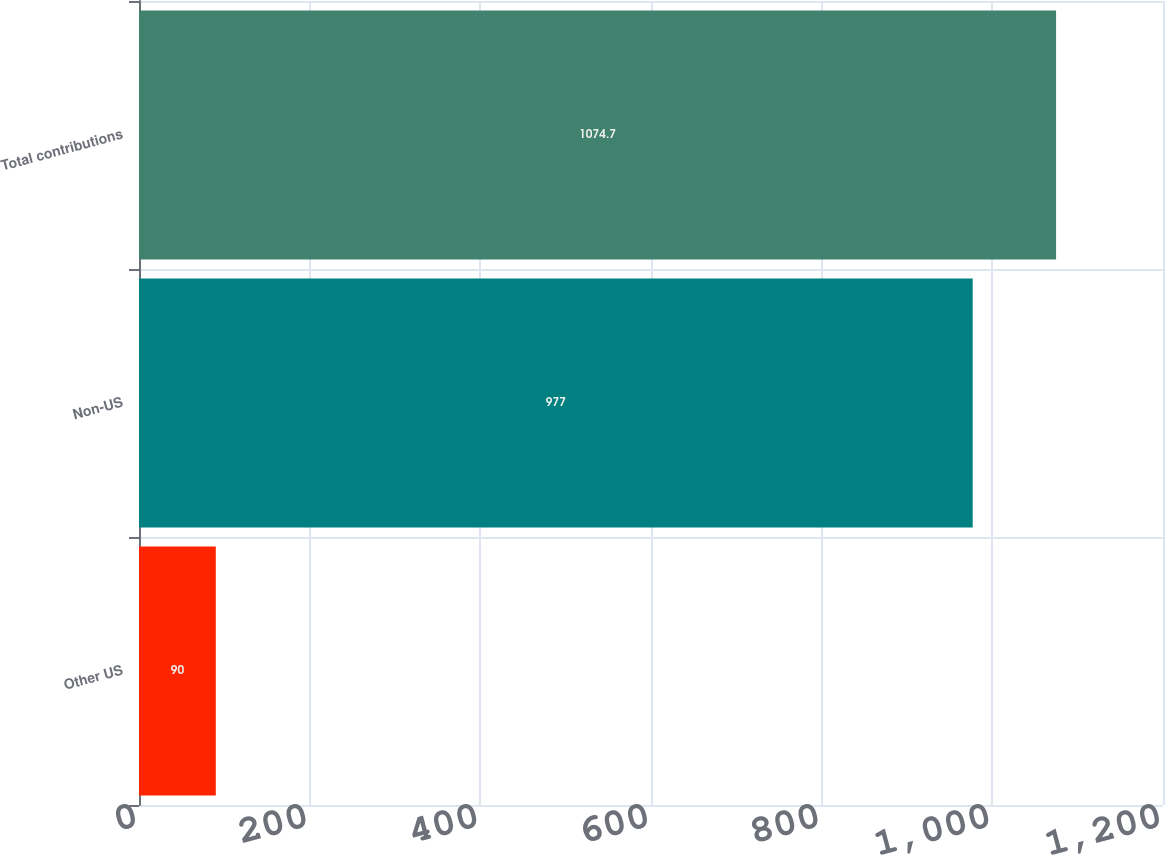Convert chart to OTSL. <chart><loc_0><loc_0><loc_500><loc_500><bar_chart><fcel>Other US<fcel>Non-US<fcel>Total contributions<nl><fcel>90<fcel>977<fcel>1074.7<nl></chart> 